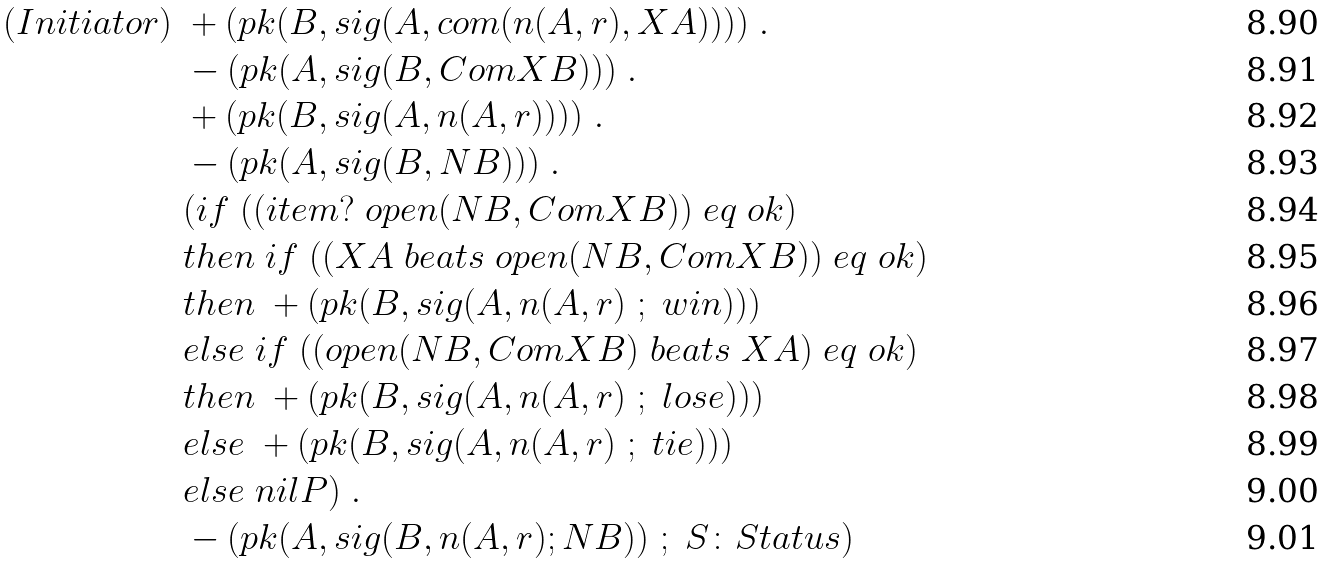<formula> <loc_0><loc_0><loc_500><loc_500>( I n i t i a t o r ) \ & + ( p k ( B , s i g ( A , c o m ( n ( A , r ) , X A ) ) ) ) \ . \\ & - ( p k ( A , s i g ( B , C o m X B ) ) ) \ . \\ & + ( p k ( B , s i g ( A , n ( A , r ) ) ) ) \ . \\ & - ( p k ( A , s i g ( B , N B ) ) ) \ . \\ & ( i f \ ( ( i t e m ? \ o p e n ( N B , C o m X B ) ) \ e q \ o k ) \\ & t h e n \ i f \ ( ( X A \ b e a t s \ o p e n ( N B , C o m X B ) ) \ e q \ o k ) \\ & t h e n \ + ( p k ( B , s i g ( A , n ( A , r ) \ ; \ w i n ) ) ) \\ & e l s e \ i f \ ( ( o p e n ( N B , C o m X B ) \ b e a t s \ X A ) \ e q \ o k ) \\ & t h e n \ + ( p k ( B , s i g ( A , n ( A , r ) \ ; \ l o s e ) ) ) \\ & e l s e \ + ( p k ( B , s i g ( A , n ( A , r ) \ ; \ t i e ) ) ) \\ & e l s e \ n i l P ) \ . \\ & - ( p k ( A , s i g ( B , n ( A , r ) ; N B ) ) \ ; \ S { \colon } S t a t u s )</formula> 